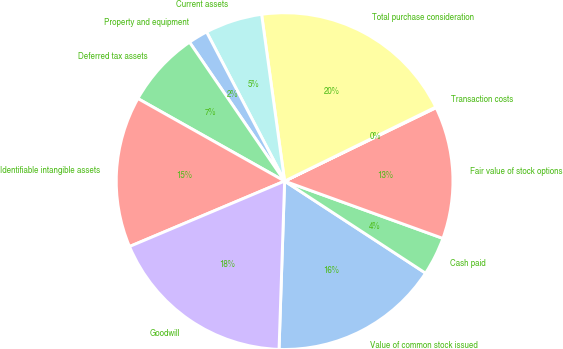<chart> <loc_0><loc_0><loc_500><loc_500><pie_chart><fcel>Value of common stock issued<fcel>Cash paid<fcel>Fair value of stock options<fcel>Transaction costs<fcel>Total purchase consideration<fcel>Current assets<fcel>Property and equipment<fcel>Deferred tax assets<fcel>Identifiable intangible assets<fcel>Goodwill<nl><fcel>16.32%<fcel>3.68%<fcel>12.71%<fcel>0.07%<fcel>19.93%<fcel>5.49%<fcel>1.88%<fcel>7.29%<fcel>14.51%<fcel>18.12%<nl></chart> 